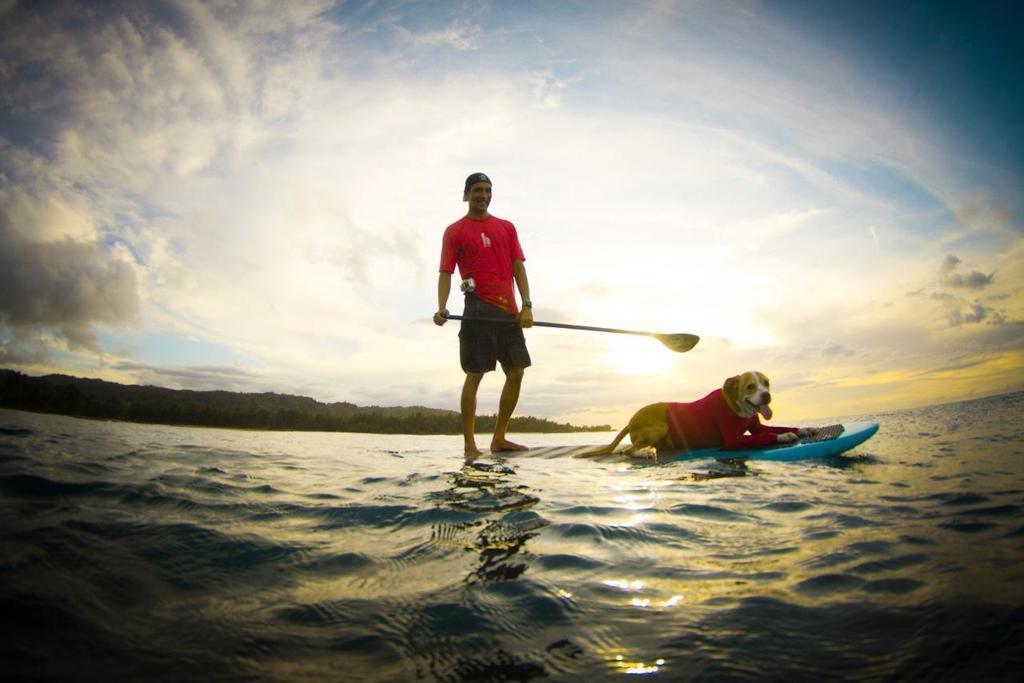How would you summarize this image in a sentence or two? In the image there is a dog laying on a surfing board and behind the dog there is a man, the surfing board is floating on the water surface, in the background there is a mountain. 